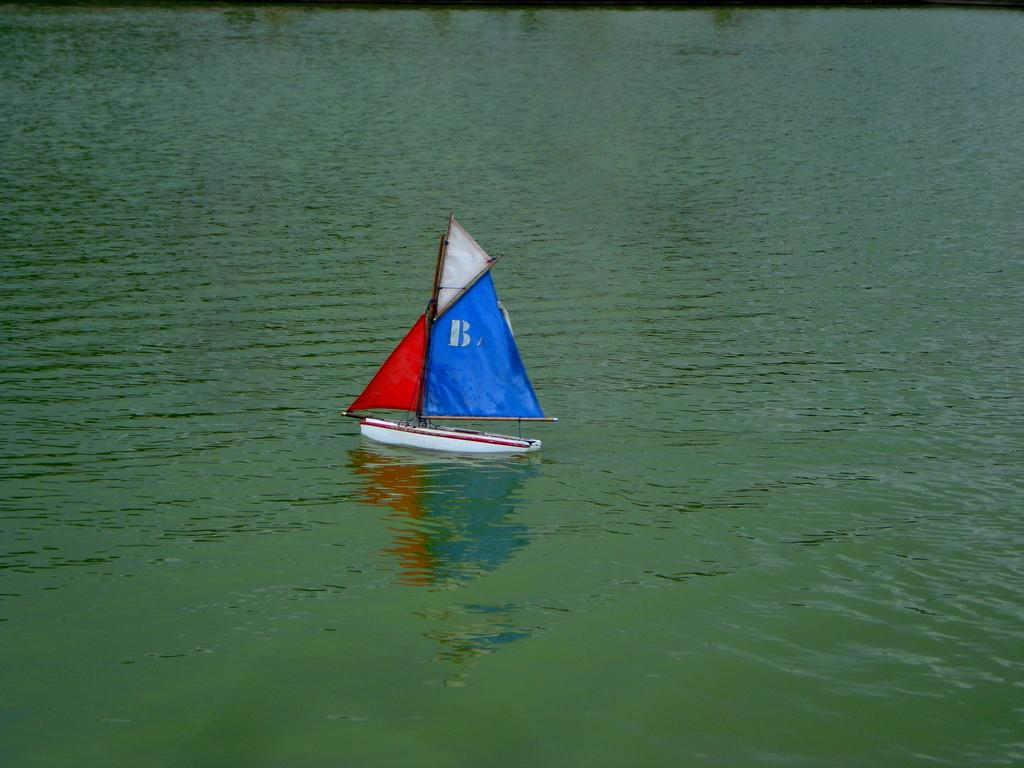What is the primary element visible in the image? There is water in the image. What is the color of the water in the image? The water appears to be green in color. What type of vehicle is present in the image? There is a boat in the image. What colors are used to paint the boat? The boat is white, red, and blue in color. Where is the boat located in the image? The boat is on the surface of the water. Can you see the mom holding a bead in the image? There is no mom or bead present in the image. Is there a tiger swimming in the green water in the image? There is no tiger visible in the image; it only features water and a boat. 